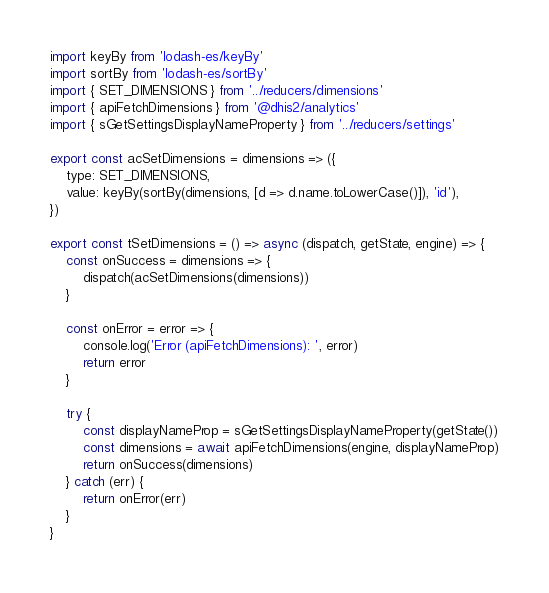<code> <loc_0><loc_0><loc_500><loc_500><_JavaScript_>import keyBy from 'lodash-es/keyBy'
import sortBy from 'lodash-es/sortBy'
import { SET_DIMENSIONS } from '../reducers/dimensions'
import { apiFetchDimensions } from '@dhis2/analytics'
import { sGetSettingsDisplayNameProperty } from '../reducers/settings'

export const acSetDimensions = dimensions => ({
    type: SET_DIMENSIONS,
    value: keyBy(sortBy(dimensions, [d => d.name.toLowerCase()]), 'id'),
})

export const tSetDimensions = () => async (dispatch, getState, engine) => {
    const onSuccess = dimensions => {
        dispatch(acSetDimensions(dimensions))
    }

    const onError = error => {
        console.log('Error (apiFetchDimensions): ', error)
        return error
    }

    try {
        const displayNameProp = sGetSettingsDisplayNameProperty(getState())
        const dimensions = await apiFetchDimensions(engine, displayNameProp)
        return onSuccess(dimensions)
    } catch (err) {
        return onError(err)
    }
}
</code> 